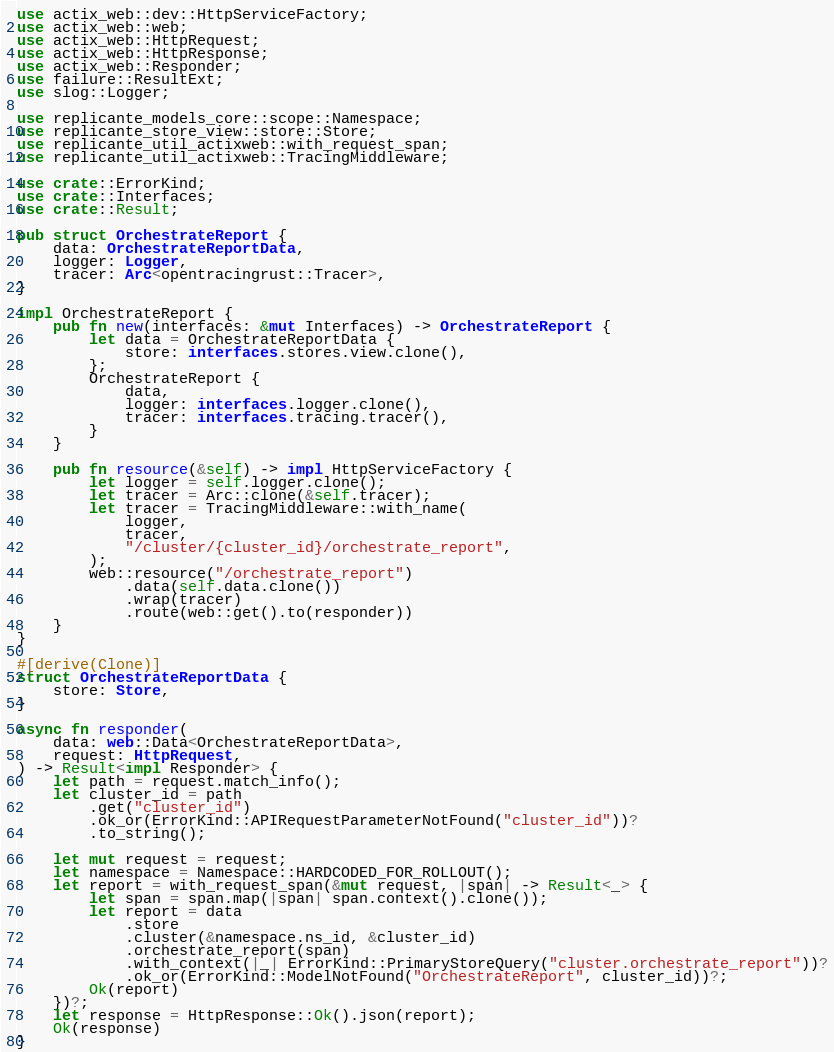Convert code to text. <code><loc_0><loc_0><loc_500><loc_500><_Rust_>use actix_web::dev::HttpServiceFactory;
use actix_web::web;
use actix_web::HttpRequest;
use actix_web::HttpResponse;
use actix_web::Responder;
use failure::ResultExt;
use slog::Logger;

use replicante_models_core::scope::Namespace;
use replicante_store_view::store::Store;
use replicante_util_actixweb::with_request_span;
use replicante_util_actixweb::TracingMiddleware;

use crate::ErrorKind;
use crate::Interfaces;
use crate::Result;

pub struct OrchestrateReport {
    data: OrchestrateReportData,
    logger: Logger,
    tracer: Arc<opentracingrust::Tracer>,
}

impl OrchestrateReport {
    pub fn new(interfaces: &mut Interfaces) -> OrchestrateReport {
        let data = OrchestrateReportData {
            store: interfaces.stores.view.clone(),
        };
        OrchestrateReport {
            data,
            logger: interfaces.logger.clone(),
            tracer: interfaces.tracing.tracer(),
        }
    }

    pub fn resource(&self) -> impl HttpServiceFactory {
        let logger = self.logger.clone();
        let tracer = Arc::clone(&self.tracer);
        let tracer = TracingMiddleware::with_name(
            logger,
            tracer,
            "/cluster/{cluster_id}/orchestrate_report",
        );
        web::resource("/orchestrate_report")
            .data(self.data.clone())
            .wrap(tracer)
            .route(web::get().to(responder))
    }
}

#[derive(Clone)]
struct OrchestrateReportData {
    store: Store,
}

async fn responder(
    data: web::Data<OrchestrateReportData>,
    request: HttpRequest,
) -> Result<impl Responder> {
    let path = request.match_info();
    let cluster_id = path
        .get("cluster_id")
        .ok_or(ErrorKind::APIRequestParameterNotFound("cluster_id"))?
        .to_string();

    let mut request = request;
    let namespace = Namespace::HARDCODED_FOR_ROLLOUT();
    let report = with_request_span(&mut request, |span| -> Result<_> {
        let span = span.map(|span| span.context().clone());
        let report = data
            .store
            .cluster(&namespace.ns_id, &cluster_id)
            .orchestrate_report(span)
            .with_context(|_| ErrorKind::PrimaryStoreQuery("cluster.orchestrate_report"))?
            .ok_or(ErrorKind::ModelNotFound("OrchestrateReport", cluster_id))?;
        Ok(report)
    })?;
    let response = HttpResponse::Ok().json(report);
    Ok(response)
}
</code> 